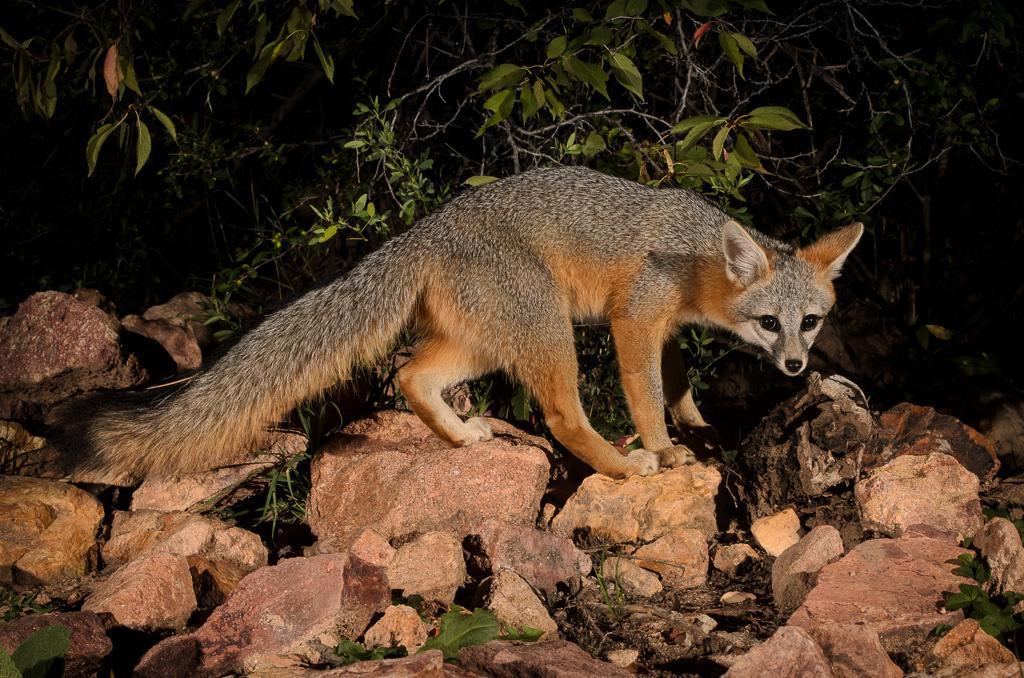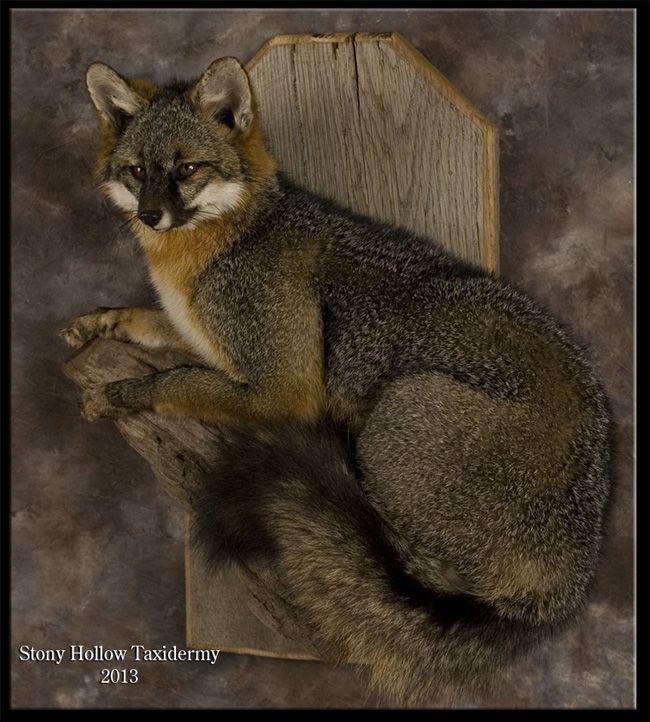The first image is the image on the left, the second image is the image on the right. For the images displayed, is the sentence "There are two foxes in the image to the right, and one in the other image." factually correct? Answer yes or no. No. The first image is the image on the left, the second image is the image on the right. Analyze the images presented: Is the assertion "The left image features one fox in a curled resting pose, and the right image features two foxes, with one reclining on the flat surface of a cut log section." valid? Answer yes or no. No. 